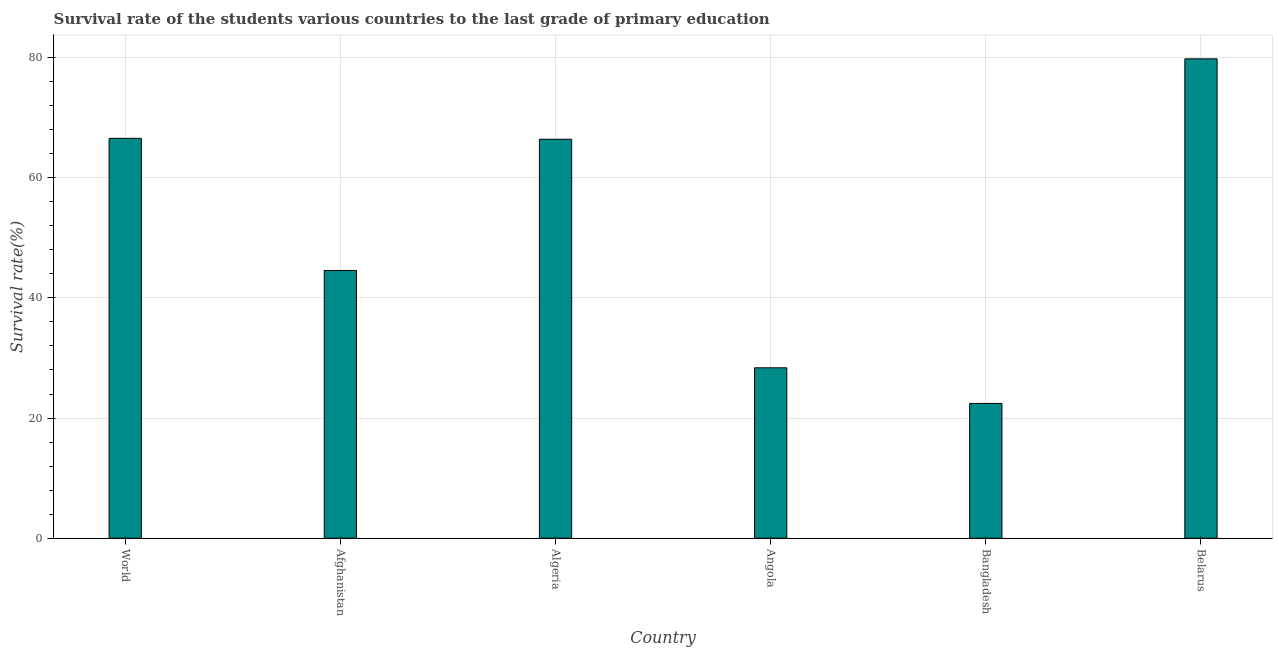Does the graph contain grids?
Ensure brevity in your answer.  Yes. What is the title of the graph?
Make the answer very short. Survival rate of the students various countries to the last grade of primary education. What is the label or title of the Y-axis?
Give a very brief answer. Survival rate(%). What is the survival rate in primary education in Afghanistan?
Provide a succinct answer. 44.56. Across all countries, what is the maximum survival rate in primary education?
Give a very brief answer. 79.78. Across all countries, what is the minimum survival rate in primary education?
Provide a succinct answer. 22.44. In which country was the survival rate in primary education maximum?
Provide a short and direct response. Belarus. What is the sum of the survival rate in primary education?
Keep it short and to the point. 308.1. What is the difference between the survival rate in primary education in Belarus and World?
Ensure brevity in your answer.  13.23. What is the average survival rate in primary education per country?
Ensure brevity in your answer.  51.35. What is the median survival rate in primary education?
Ensure brevity in your answer.  55.48. In how many countries, is the survival rate in primary education greater than 60 %?
Make the answer very short. 3. What is the ratio of the survival rate in primary education in Afghanistan to that in World?
Your answer should be compact. 0.67. Is the difference between the survival rate in primary education in Afghanistan and World greater than the difference between any two countries?
Your answer should be compact. No. What is the difference between the highest and the second highest survival rate in primary education?
Offer a terse response. 13.23. What is the difference between the highest and the lowest survival rate in primary education?
Offer a terse response. 57.35. Are all the bars in the graph horizontal?
Offer a very short reply. No. How many countries are there in the graph?
Your response must be concise. 6. What is the difference between two consecutive major ticks on the Y-axis?
Make the answer very short. 20. Are the values on the major ticks of Y-axis written in scientific E-notation?
Provide a short and direct response. No. What is the Survival rate(%) of World?
Provide a succinct answer. 66.55. What is the Survival rate(%) in Afghanistan?
Give a very brief answer. 44.56. What is the Survival rate(%) in Algeria?
Give a very brief answer. 66.4. What is the Survival rate(%) in Angola?
Ensure brevity in your answer.  28.37. What is the Survival rate(%) in Bangladesh?
Your answer should be compact. 22.44. What is the Survival rate(%) in Belarus?
Provide a short and direct response. 79.78. What is the difference between the Survival rate(%) in World and Afghanistan?
Provide a short and direct response. 21.99. What is the difference between the Survival rate(%) in World and Algeria?
Provide a succinct answer. 0.15. What is the difference between the Survival rate(%) in World and Angola?
Your answer should be very brief. 38.19. What is the difference between the Survival rate(%) in World and Bangladesh?
Keep it short and to the point. 44.12. What is the difference between the Survival rate(%) in World and Belarus?
Provide a succinct answer. -13.23. What is the difference between the Survival rate(%) in Afghanistan and Algeria?
Offer a very short reply. -21.84. What is the difference between the Survival rate(%) in Afghanistan and Angola?
Provide a succinct answer. 16.2. What is the difference between the Survival rate(%) in Afghanistan and Bangladesh?
Offer a terse response. 22.13. What is the difference between the Survival rate(%) in Afghanistan and Belarus?
Provide a succinct answer. -35.22. What is the difference between the Survival rate(%) in Algeria and Angola?
Your answer should be compact. 38.04. What is the difference between the Survival rate(%) in Algeria and Bangladesh?
Provide a short and direct response. 43.97. What is the difference between the Survival rate(%) in Algeria and Belarus?
Keep it short and to the point. -13.38. What is the difference between the Survival rate(%) in Angola and Bangladesh?
Ensure brevity in your answer.  5.93. What is the difference between the Survival rate(%) in Angola and Belarus?
Keep it short and to the point. -51.42. What is the difference between the Survival rate(%) in Bangladesh and Belarus?
Provide a succinct answer. -57.35. What is the ratio of the Survival rate(%) in World to that in Afghanistan?
Offer a very short reply. 1.49. What is the ratio of the Survival rate(%) in World to that in Angola?
Provide a short and direct response. 2.35. What is the ratio of the Survival rate(%) in World to that in Bangladesh?
Make the answer very short. 2.97. What is the ratio of the Survival rate(%) in World to that in Belarus?
Ensure brevity in your answer.  0.83. What is the ratio of the Survival rate(%) in Afghanistan to that in Algeria?
Provide a succinct answer. 0.67. What is the ratio of the Survival rate(%) in Afghanistan to that in Angola?
Offer a very short reply. 1.57. What is the ratio of the Survival rate(%) in Afghanistan to that in Bangladesh?
Provide a short and direct response. 1.99. What is the ratio of the Survival rate(%) in Afghanistan to that in Belarus?
Keep it short and to the point. 0.56. What is the ratio of the Survival rate(%) in Algeria to that in Angola?
Your answer should be very brief. 2.34. What is the ratio of the Survival rate(%) in Algeria to that in Bangladesh?
Offer a very short reply. 2.96. What is the ratio of the Survival rate(%) in Algeria to that in Belarus?
Your response must be concise. 0.83. What is the ratio of the Survival rate(%) in Angola to that in Bangladesh?
Ensure brevity in your answer.  1.26. What is the ratio of the Survival rate(%) in Angola to that in Belarus?
Give a very brief answer. 0.36. What is the ratio of the Survival rate(%) in Bangladesh to that in Belarus?
Make the answer very short. 0.28. 